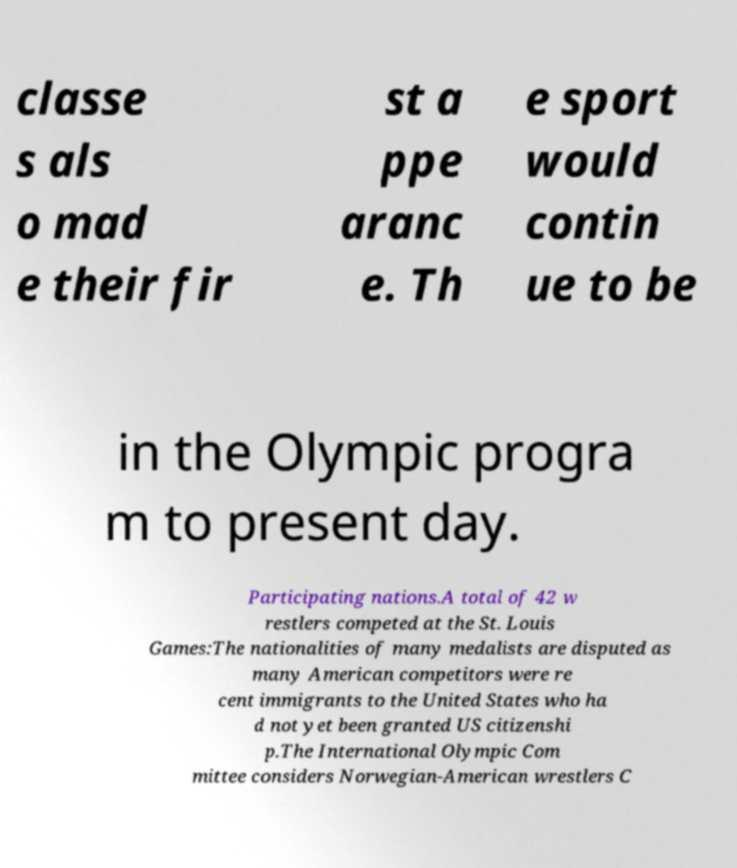For documentation purposes, I need the text within this image transcribed. Could you provide that? classe s als o mad e their fir st a ppe aranc e. Th e sport would contin ue to be in the Olympic progra m to present day. Participating nations.A total of 42 w restlers competed at the St. Louis Games:The nationalities of many medalists are disputed as many American competitors were re cent immigrants to the United States who ha d not yet been granted US citizenshi p.The International Olympic Com mittee considers Norwegian-American wrestlers C 